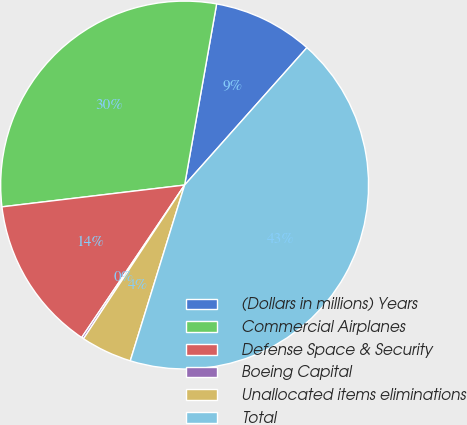Convert chart to OTSL. <chart><loc_0><loc_0><loc_500><loc_500><pie_chart><fcel>(Dollars in millions) Years<fcel>Commercial Airplanes<fcel>Defense Space & Security<fcel>Boeing Capital<fcel>Unallocated items eliminations<fcel>Total<nl><fcel>8.79%<fcel>29.68%<fcel>13.66%<fcel>0.19%<fcel>4.49%<fcel>43.2%<nl></chart> 